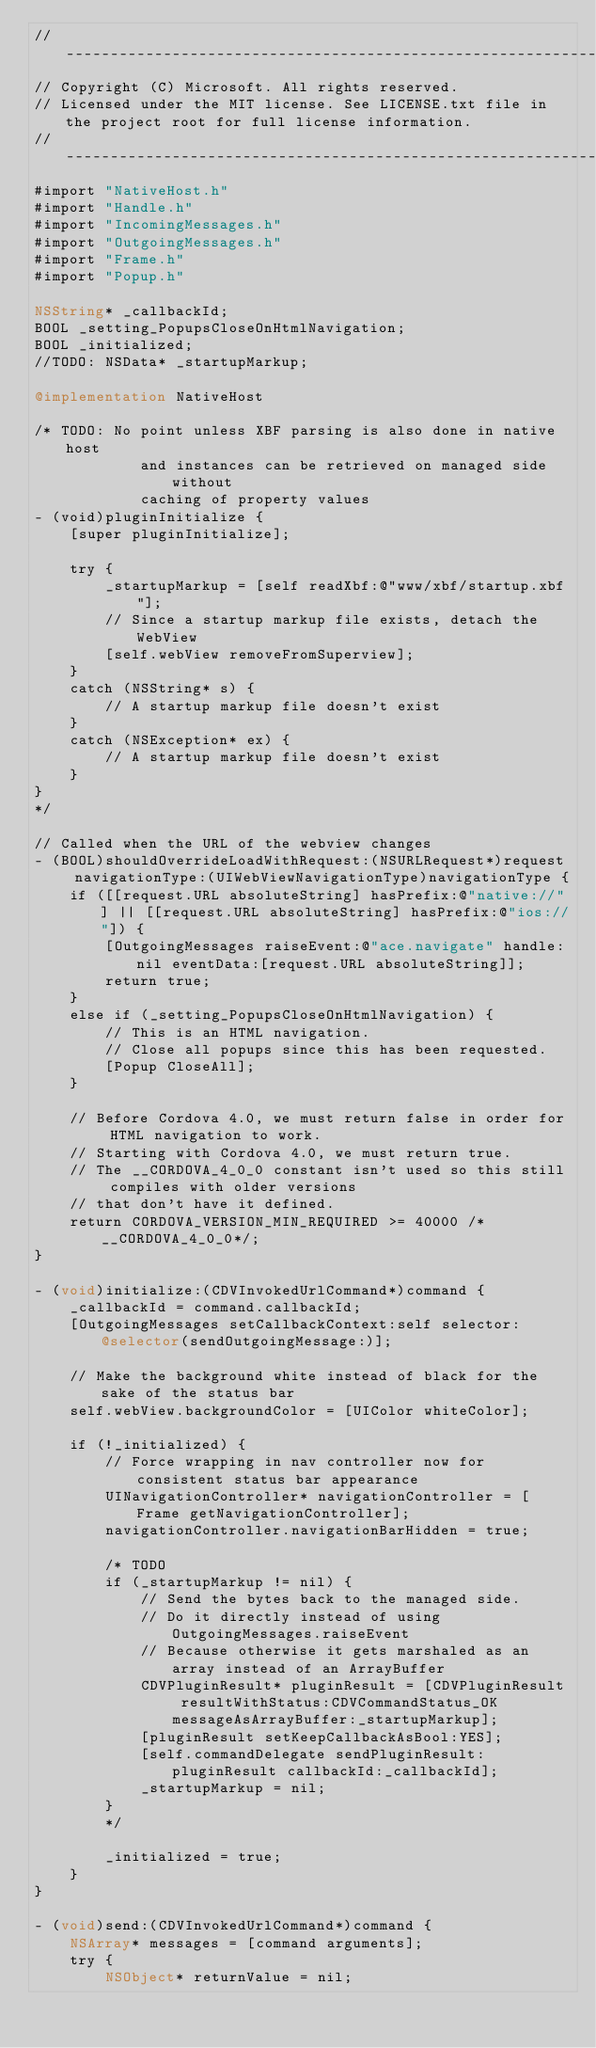<code> <loc_0><loc_0><loc_500><loc_500><_ObjectiveC_>//-------------------------------------------------------------------------------------------------------
// Copyright (C) Microsoft. All rights reserved.
// Licensed under the MIT license. See LICENSE.txt file in the project root for full license information.
//-------------------------------------------------------------------------------------------------------
#import "NativeHost.h"
#import "Handle.h"
#import "IncomingMessages.h"
#import "OutgoingMessages.h"
#import "Frame.h"
#import "Popup.h"

NSString* _callbackId;
BOOL _setting_PopupsCloseOnHtmlNavigation;
BOOL _initialized;
//TODO: NSData* _startupMarkup;

@implementation NativeHost

/* TODO: No point unless XBF parsing is also done in native host
            and instances can be retrieved on managed side without
            caching of property values
- (void)pluginInitialize {
    [super pluginInitialize];

    try {
        _startupMarkup = [self readXbf:@"www/xbf/startup.xbf"];
        // Since a startup markup file exists, detach the WebView
        [self.webView removeFromSuperview];
    }
    catch (NSString* s) {
        // A startup markup file doesn't exist
    }
    catch (NSException* ex) {
        // A startup markup file doesn't exist
    }
}
*/

// Called when the URL of the webview changes
- (BOOL)shouldOverrideLoadWithRequest:(NSURLRequest*)request navigationType:(UIWebViewNavigationType)navigationType {
    if ([[request.URL absoluteString] hasPrefix:@"native://"] || [[request.URL absoluteString] hasPrefix:@"ios://"]) {
        [OutgoingMessages raiseEvent:@"ace.navigate" handle:nil eventData:[request.URL absoluteString]];
        return true;
    }
    else if (_setting_PopupsCloseOnHtmlNavigation) {
        // This is an HTML navigation.
        // Close all popups since this has been requested.
        [Popup CloseAll];
    }
    
    // Before Cordova 4.0, we must return false in order for HTML navigation to work.
    // Starting with Cordova 4.0, we must return true.
    // The __CORDOVA_4_0_0 constant isn't used so this still compiles with older versions
    // that don't have it defined.
    return CORDOVA_VERSION_MIN_REQUIRED >= 40000 /*__CORDOVA_4_0_0*/;
}

- (void)initialize:(CDVInvokedUrlCommand*)command {
    _callbackId = command.callbackId;
    [OutgoingMessages setCallbackContext:self selector:@selector(sendOutgoingMessage:)];

    // Make the background white instead of black for the sake of the status bar
    self.webView.backgroundColor = [UIColor whiteColor];

    if (!_initialized) {
        // Force wrapping in nav controller now for consistent status bar appearance
        UINavigationController* navigationController = [Frame getNavigationController];
        navigationController.navigationBarHidden = true;

        /* TODO
        if (_startupMarkup != nil) {
            // Send the bytes back to the managed side.
            // Do it directly instead of using OutgoingMessages.raiseEvent
            // Because otherwise it gets marshaled as an array instead of an ArrayBuffer
            CDVPluginResult* pluginResult = [CDVPluginResult resultWithStatus:CDVCommandStatus_OK messageAsArrayBuffer:_startupMarkup];
            [pluginResult setKeepCallbackAsBool:YES];
            [self.commandDelegate sendPluginResult:pluginResult callbackId:_callbackId];
            _startupMarkup = nil;
        }
        */

        _initialized = true;
    }
}

- (void)send:(CDVInvokedUrlCommand*)command {
    NSArray* messages = [command arguments];
    try {
        NSObject* returnValue = nil;</code> 